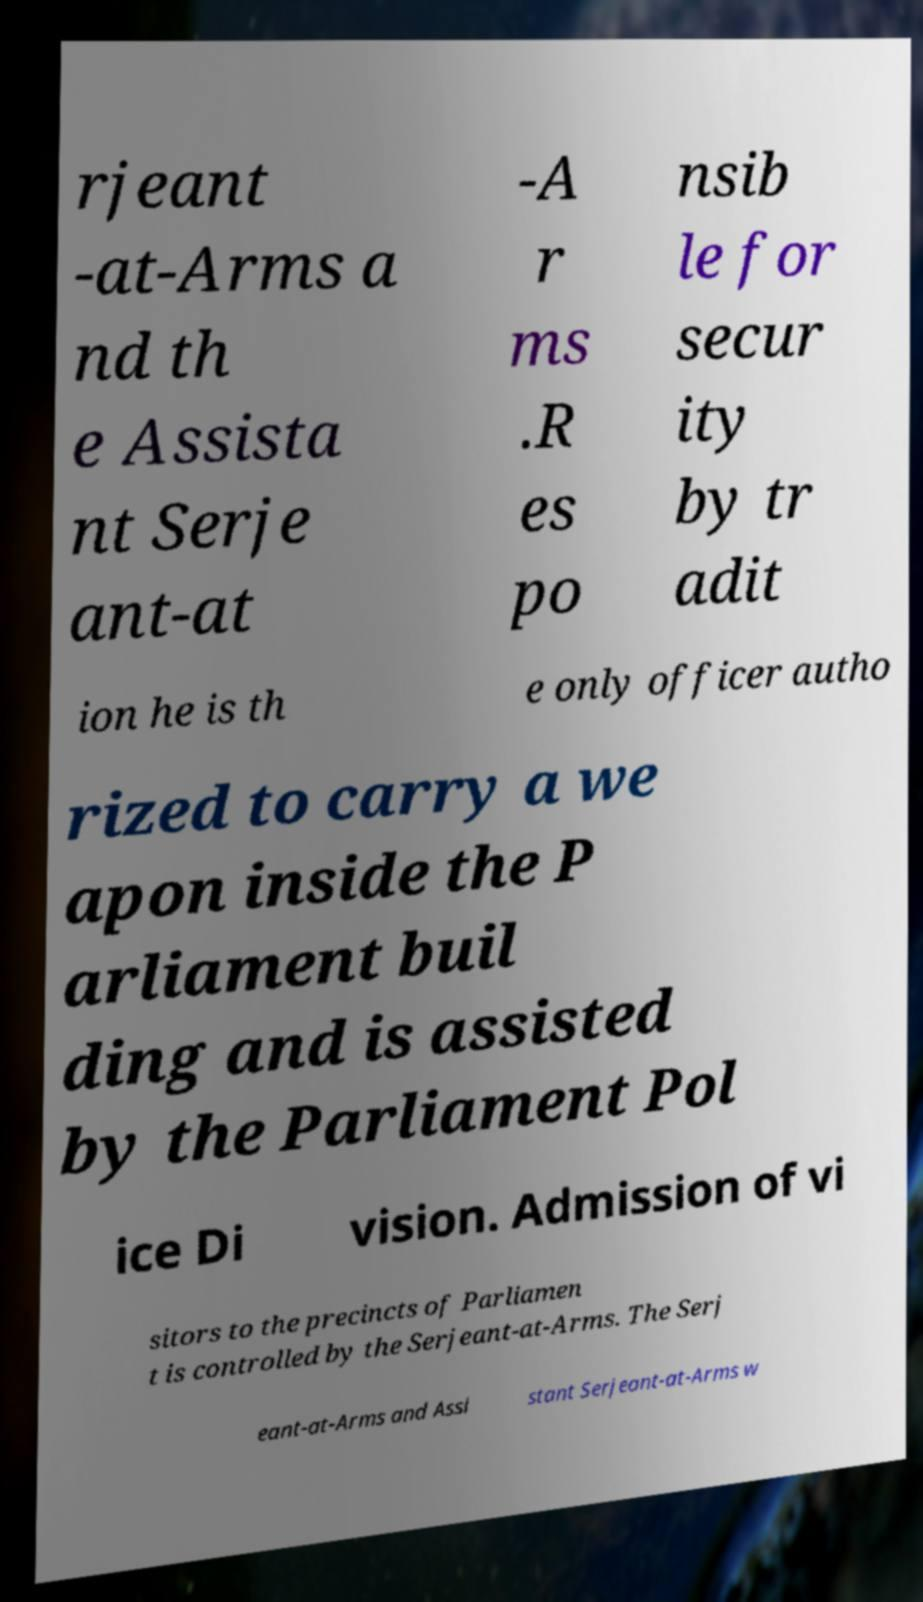I need the written content from this picture converted into text. Can you do that? rjeant -at-Arms a nd th e Assista nt Serje ant-at -A r ms .R es po nsib le for secur ity by tr adit ion he is th e only officer autho rized to carry a we apon inside the P arliament buil ding and is assisted by the Parliament Pol ice Di vision. Admission of vi sitors to the precincts of Parliamen t is controlled by the Serjeant-at-Arms. The Serj eant-at-Arms and Assi stant Serjeant-at-Arms w 